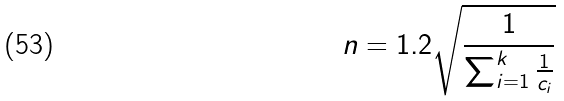<formula> <loc_0><loc_0><loc_500><loc_500>n = 1 . 2 \sqrt { \frac { 1 } { \sum _ { i = 1 } ^ { k } \frac { 1 } { c _ { i } } } }</formula> 